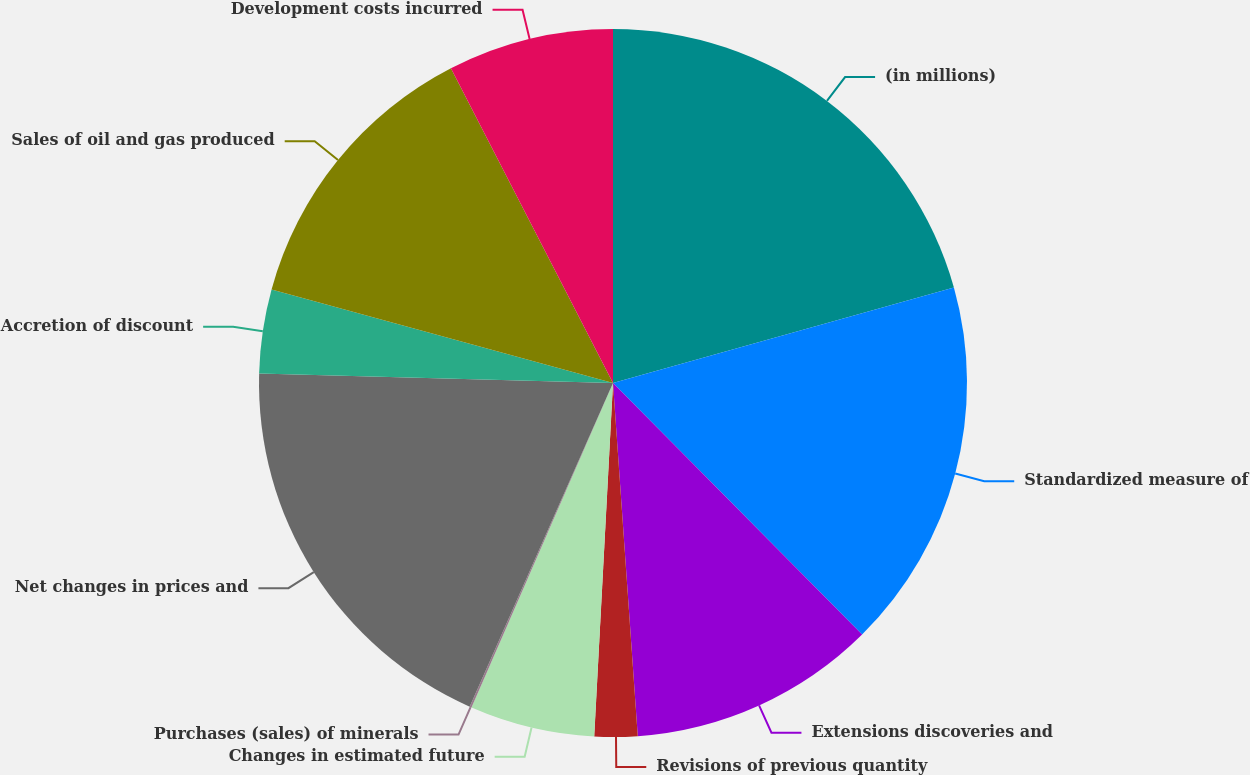Convert chart to OTSL. <chart><loc_0><loc_0><loc_500><loc_500><pie_chart><fcel>(in millions)<fcel>Standardized measure of<fcel>Extensions discoveries and<fcel>Revisions of previous quantity<fcel>Changes in estimated future<fcel>Purchases (sales) of minerals<fcel>Net changes in prices and<fcel>Accretion of discount<fcel>Sales of oil and gas produced<fcel>Development costs incurred<nl><fcel>20.66%<fcel>16.92%<fcel>11.31%<fcel>1.96%<fcel>5.7%<fcel>0.09%<fcel>18.79%<fcel>3.83%<fcel>13.18%<fcel>7.57%<nl></chart> 